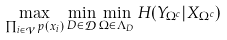Convert formula to latex. <formula><loc_0><loc_0><loc_500><loc_500>\max _ { \prod _ { i \in \mathcal { V } } p ( x _ { i } ) } \min _ { D \in \mathcal { D } } \min _ { \Omega \in \Lambda _ { D } } H ( Y _ { \Omega ^ { c } } | X _ { \Omega ^ { c } } )</formula> 